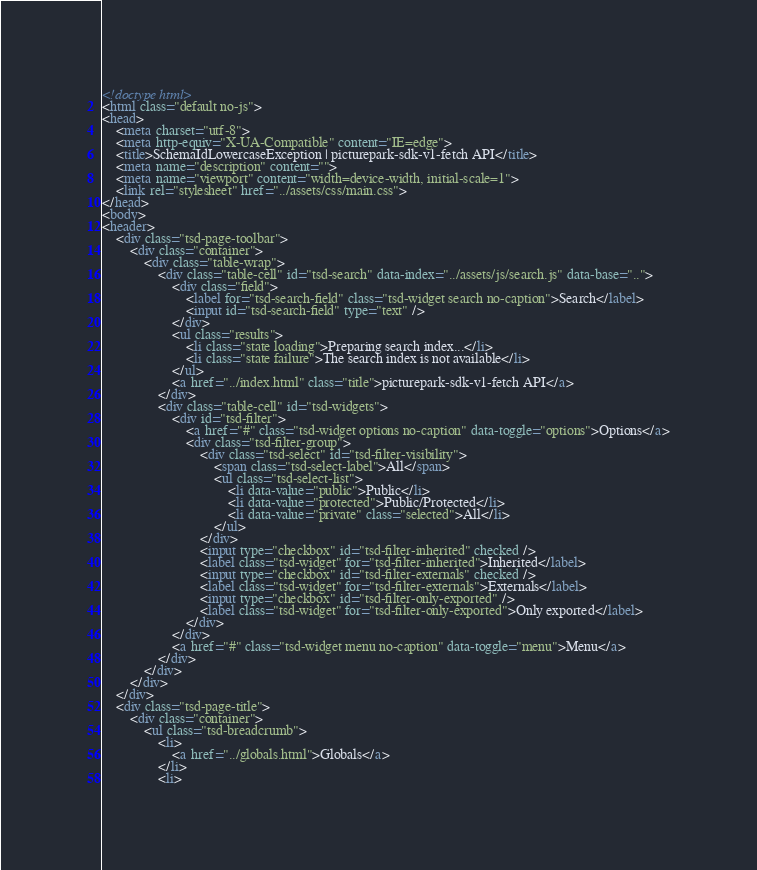<code> <loc_0><loc_0><loc_500><loc_500><_HTML_><!doctype html>
<html class="default no-js">
<head>
	<meta charset="utf-8">
	<meta http-equiv="X-UA-Compatible" content="IE=edge">
	<title>SchemaIdLowercaseException | picturepark-sdk-v1-fetch API</title>
	<meta name="description" content="">
	<meta name="viewport" content="width=device-width, initial-scale=1">
	<link rel="stylesheet" href="../assets/css/main.css">
</head>
<body>
<header>
	<div class="tsd-page-toolbar">
		<div class="container">
			<div class="table-wrap">
				<div class="table-cell" id="tsd-search" data-index="../assets/js/search.js" data-base="..">
					<div class="field">
						<label for="tsd-search-field" class="tsd-widget search no-caption">Search</label>
						<input id="tsd-search-field" type="text" />
					</div>
					<ul class="results">
						<li class="state loading">Preparing search index...</li>
						<li class="state failure">The search index is not available</li>
					</ul>
					<a href="../index.html" class="title">picturepark-sdk-v1-fetch API</a>
				</div>
				<div class="table-cell" id="tsd-widgets">
					<div id="tsd-filter">
						<a href="#" class="tsd-widget options no-caption" data-toggle="options">Options</a>
						<div class="tsd-filter-group">
							<div class="tsd-select" id="tsd-filter-visibility">
								<span class="tsd-select-label">All</span>
								<ul class="tsd-select-list">
									<li data-value="public">Public</li>
									<li data-value="protected">Public/Protected</li>
									<li data-value="private" class="selected">All</li>
								</ul>
							</div>
							<input type="checkbox" id="tsd-filter-inherited" checked />
							<label class="tsd-widget" for="tsd-filter-inherited">Inherited</label>
							<input type="checkbox" id="tsd-filter-externals" checked />
							<label class="tsd-widget" for="tsd-filter-externals">Externals</label>
							<input type="checkbox" id="tsd-filter-only-exported" />
							<label class="tsd-widget" for="tsd-filter-only-exported">Only exported</label>
						</div>
					</div>
					<a href="#" class="tsd-widget menu no-caption" data-toggle="menu">Menu</a>
				</div>
			</div>
		</div>
	</div>
	<div class="tsd-page-title">
		<div class="container">
			<ul class="tsd-breadcrumb">
				<li>
					<a href="../globals.html">Globals</a>
				</li>
				<li></code> 